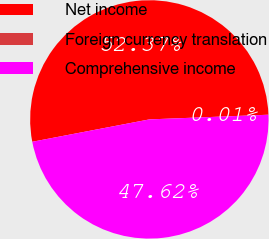Convert chart. <chart><loc_0><loc_0><loc_500><loc_500><pie_chart><fcel>Net income<fcel>Foreign currency translation<fcel>Comprehensive income<nl><fcel>52.38%<fcel>0.01%<fcel>47.62%<nl></chart> 